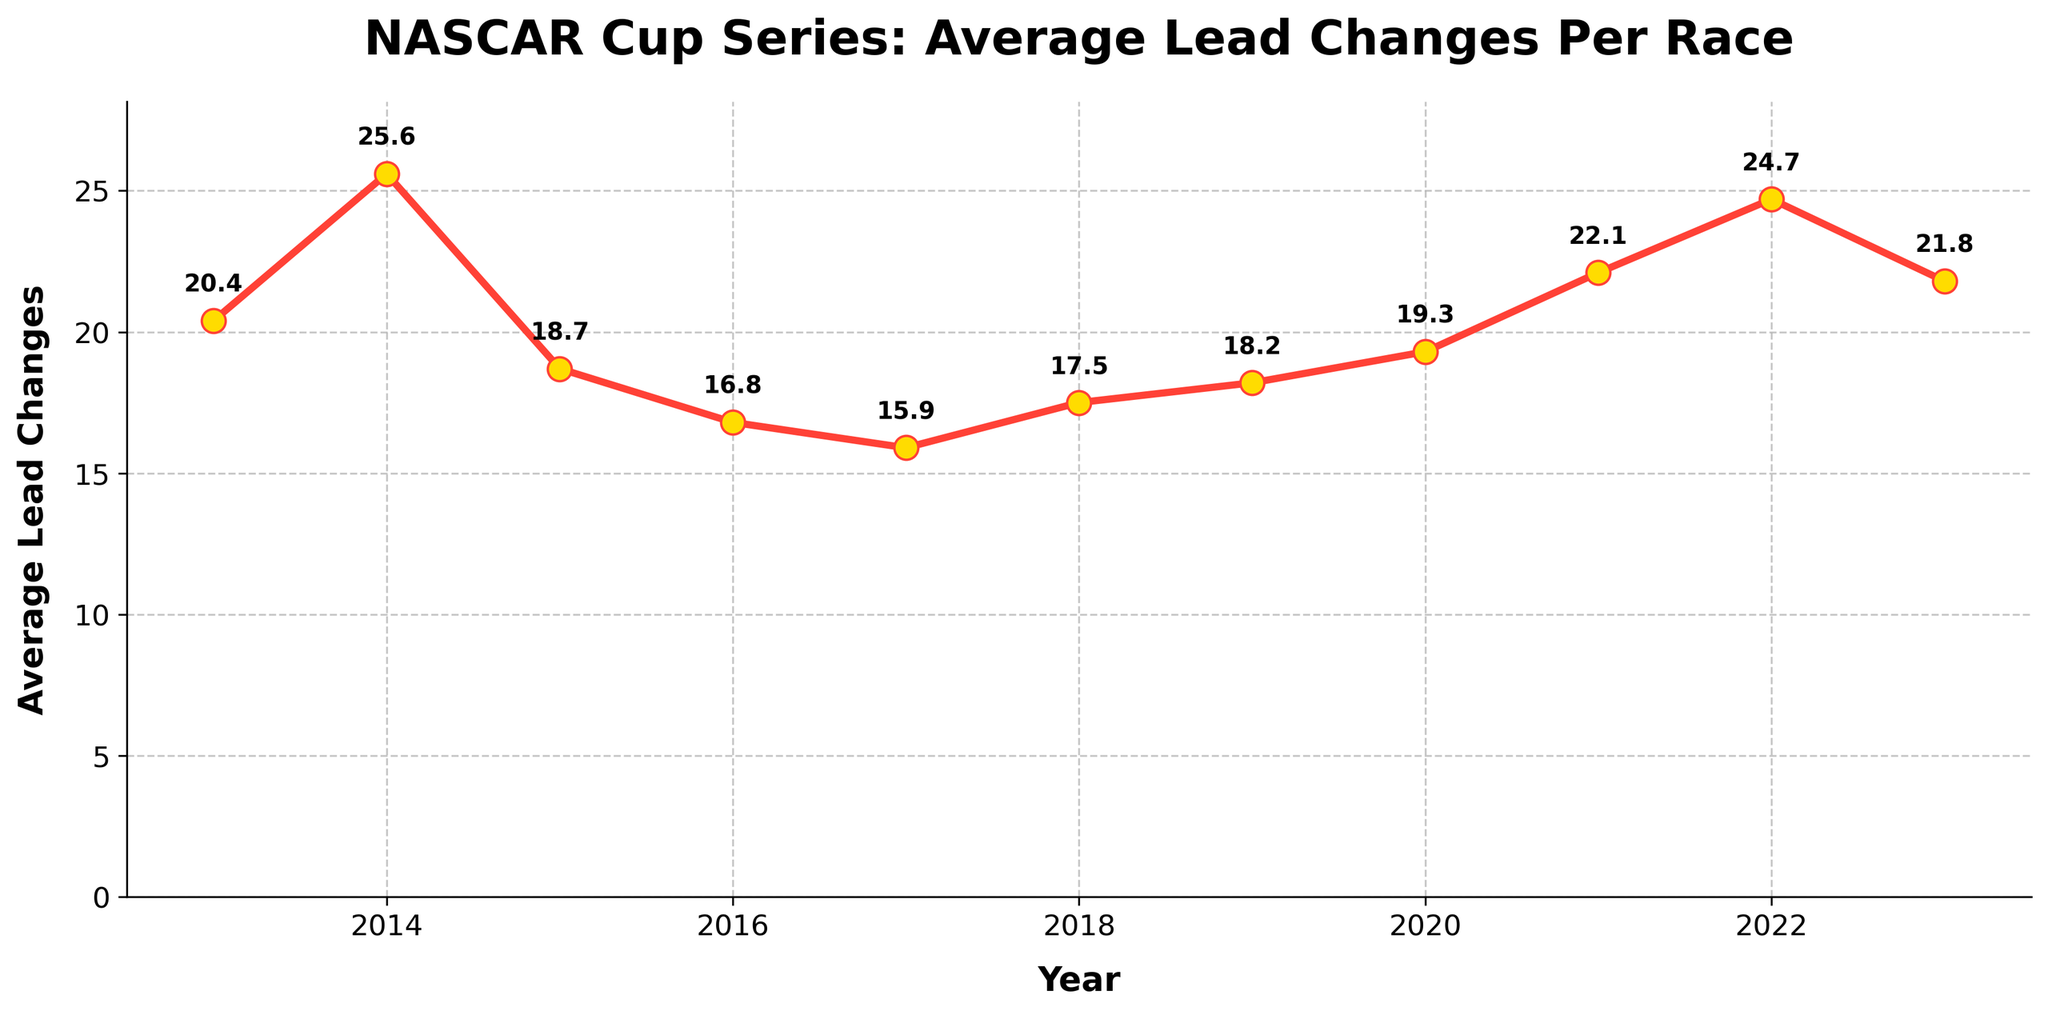what is the highest average lead changes per race? The highest point on the line graph represents the peak value. For this dataset, it occurred in 2014.
Answer: 25.6 In which year did the average lead changes per race decrease to the lowest value? To find the lowest point, check the minimum value on the y-axis. For this dataset, it reached the lowest in 2017.
Answer: 15.9 If we sum the average lead changes per race from 2013 to 2015, what is the result? Adding the values for 2013, 2014, and 2015: 20.4 + 25.6 + 18.7 = 64.7
Answer: 64.7 What is the difference in average lead changes per race between 2014 and 2017? Subtract the average lead changes in 2017 from 2014: 25.6 - 15.9 = 9.7
Answer: 9.7 Comparing 2021 and 2023, which year had a higher average lead change per race? The value for 2021 is 22.1 and for 2023 it is 21.8. Since 22.1 is greater, 2021 had a higher average lead.
Answer: 2021 How does the average in 2022 compare to the overall trend from 2013 to 2023? Observing the values, 2022 has a high average of 24.7, which is one of the peaks within the decade indicating above-average lead changes compared to other years.
Answer: Above average Does the trend from 2017 to 2019 show an increase or decrease in average lead changes per race? From 2017 (15.9) to 2019 (18.2), the values show an upward trend.
Answer: Increase Is the average lead change per race for 2015 closer to the 2014 or 2016 values? Average lead change in 2015 is 18.7. Compare with values in 2014 (25.6) and 2016 (16.8), it's closer to 2016.
Answer: 2016 By how much did the average lead changes per race change from 2020 to 2021? Subtracting 2020 from 2021: 22.1 - 19.3 = 2.8
Answer: 2.8 